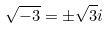Convert formula to latex. <formula><loc_0><loc_0><loc_500><loc_500>\sqrt { - 3 } = \pm \sqrt { 3 } i</formula> 